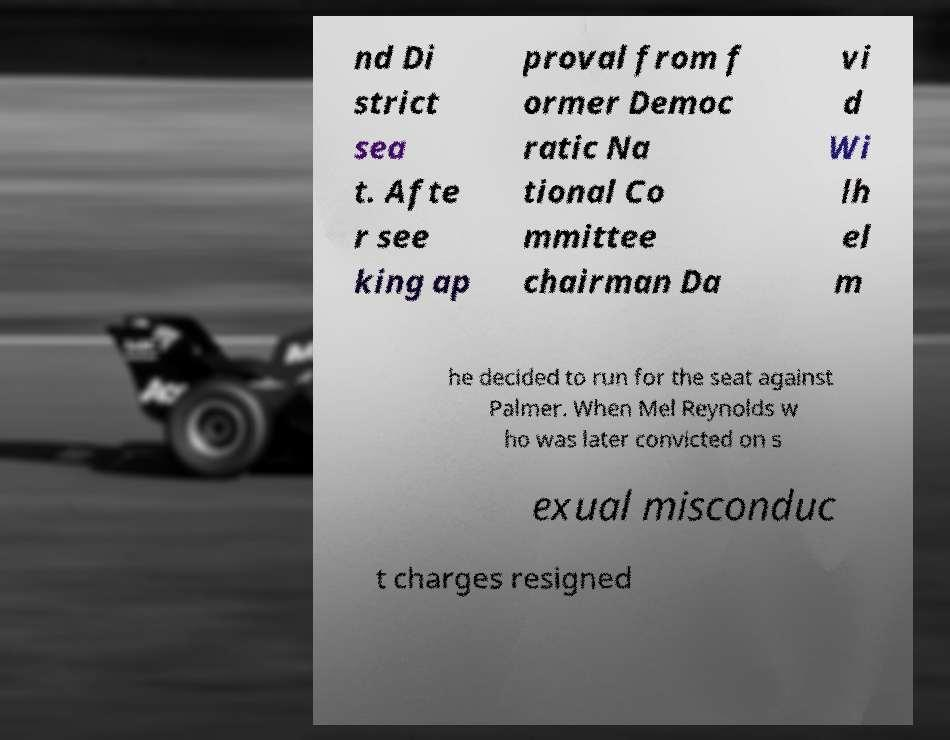Could you extract and type out the text from this image? nd Di strict sea t. Afte r see king ap proval from f ormer Democ ratic Na tional Co mmittee chairman Da vi d Wi lh el m he decided to run for the seat against Palmer. When Mel Reynolds w ho was later convicted on s exual misconduc t charges resigned 